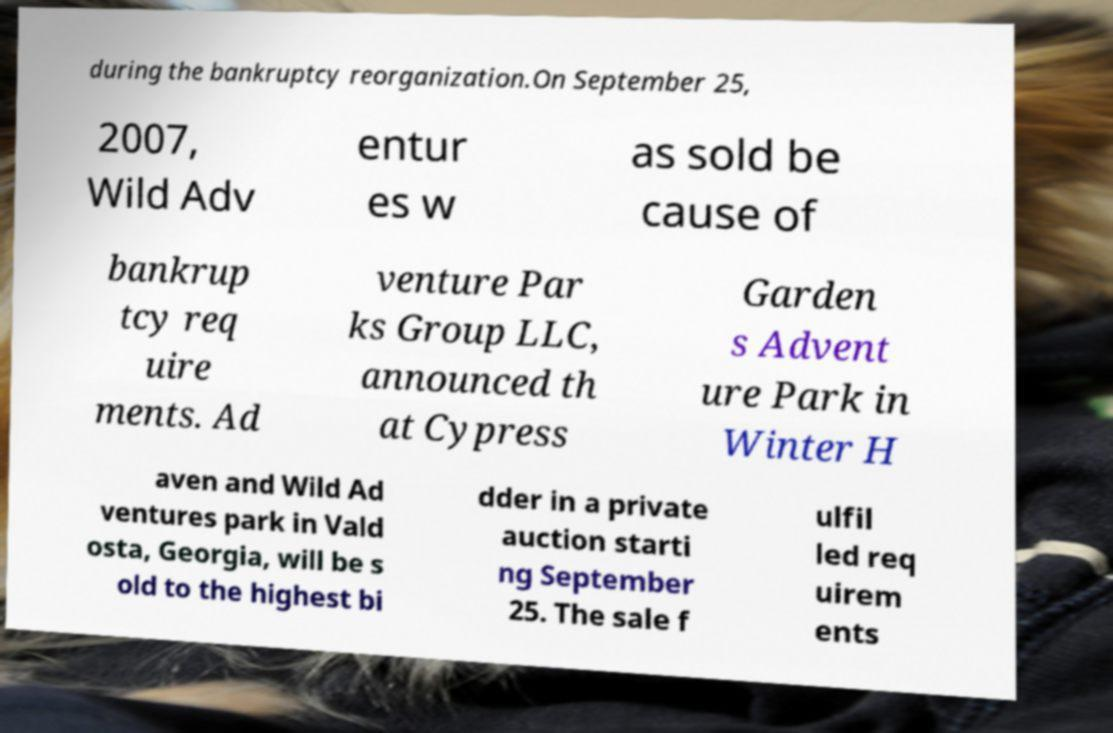What messages or text are displayed in this image? I need them in a readable, typed format. during the bankruptcy reorganization.On September 25, 2007, Wild Adv entur es w as sold be cause of bankrup tcy req uire ments. Ad venture Par ks Group LLC, announced th at Cypress Garden s Advent ure Park in Winter H aven and Wild Ad ventures park in Vald osta, Georgia, will be s old to the highest bi dder in a private auction starti ng September 25. The sale f ulfil led req uirem ents 